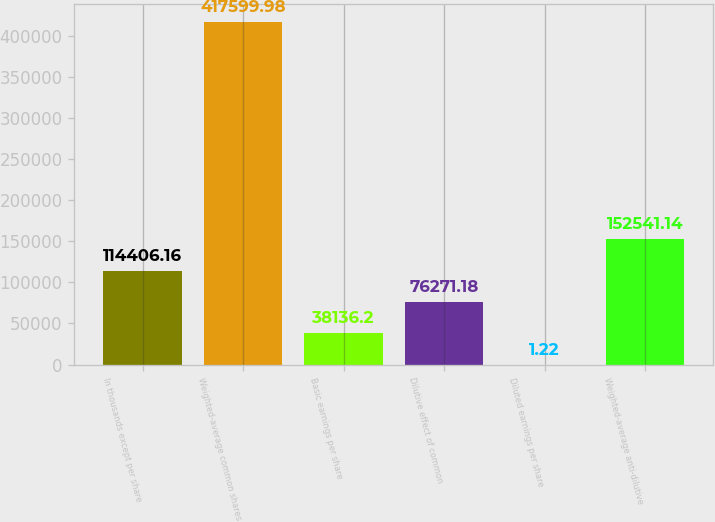Convert chart. <chart><loc_0><loc_0><loc_500><loc_500><bar_chart><fcel>In thousands except per share<fcel>Weighted-average common shares<fcel>Basic earnings per share<fcel>Dilutive effect of common<fcel>Diluted earnings per share<fcel>Weighted-average anti-dilutive<nl><fcel>114406<fcel>417600<fcel>38136.2<fcel>76271.2<fcel>1.22<fcel>152541<nl></chart> 